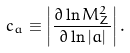<formula> <loc_0><loc_0><loc_500><loc_500>c _ { a } \equiv \left | \frac { \partial \ln M _ { Z } ^ { 2 } } { \partial \ln | a | } \right | .</formula> 